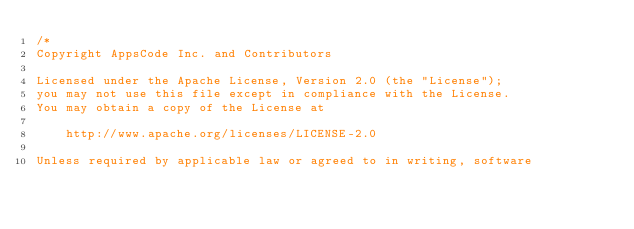Convert code to text. <code><loc_0><loc_0><loc_500><loc_500><_Go_>/*
Copyright AppsCode Inc. and Contributors

Licensed under the Apache License, Version 2.0 (the "License");
you may not use this file except in compliance with the License.
You may obtain a copy of the License at

    http://www.apache.org/licenses/LICENSE-2.0

Unless required by applicable law or agreed to in writing, software</code> 